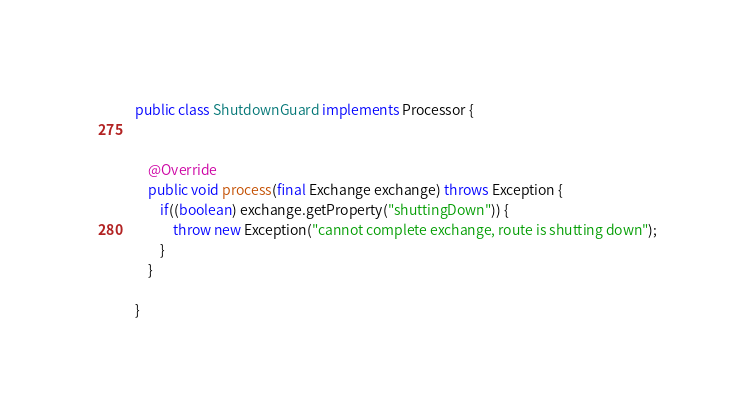Convert code to text. <code><loc_0><loc_0><loc_500><loc_500><_Java_>public class ShutdownGuard implements Processor {


    @Override
    public void process(final Exchange exchange) throws Exception {
        if((boolean) exchange.getProperty("shuttingDown")) {
            throw new Exception("cannot complete exchange, route is shutting down");
        }
    }

}
</code> 